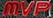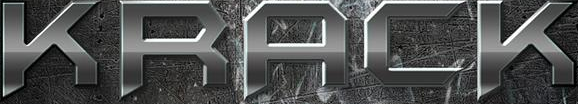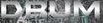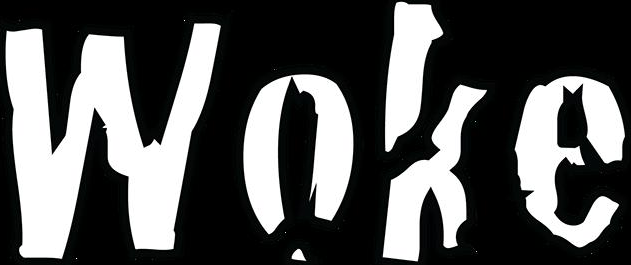Transcribe the words shown in these images in order, separated by a semicolon. MVP; KRACK; DRUM; Woke 